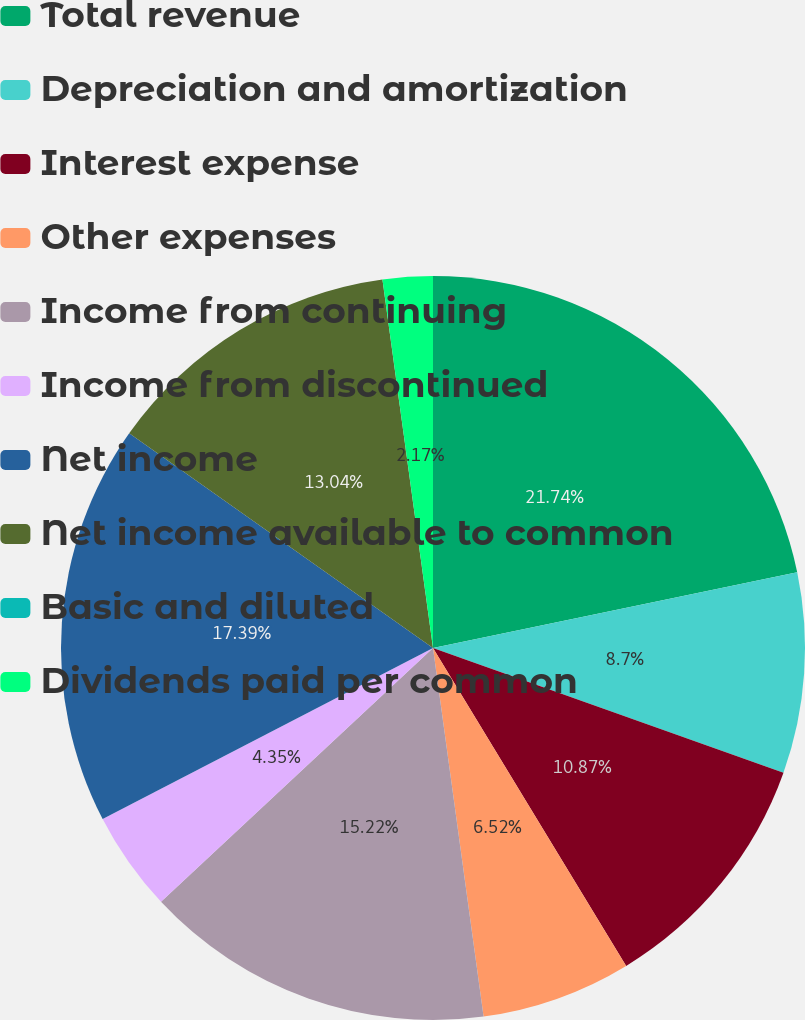Convert chart to OTSL. <chart><loc_0><loc_0><loc_500><loc_500><pie_chart><fcel>Total revenue<fcel>Depreciation and amortization<fcel>Interest expense<fcel>Other expenses<fcel>Income from continuing<fcel>Income from discontinued<fcel>Net income<fcel>Net income available to common<fcel>Basic and diluted<fcel>Dividends paid per common<nl><fcel>21.74%<fcel>8.7%<fcel>10.87%<fcel>6.52%<fcel>15.22%<fcel>4.35%<fcel>17.39%<fcel>13.04%<fcel>0.0%<fcel>2.17%<nl></chart> 